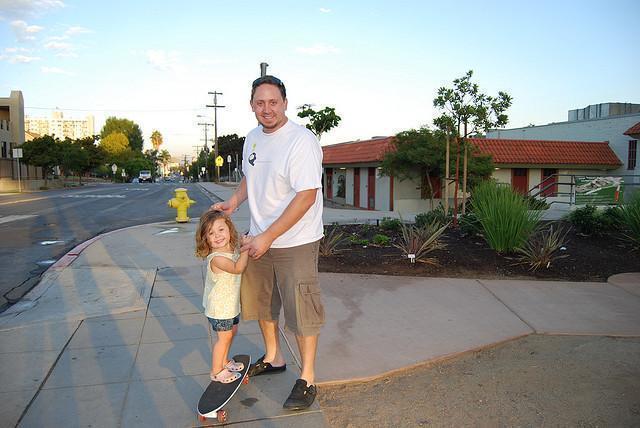What are the reddish and green plants called in the forefront of the planter?
Indicate the correct response and explain using: 'Answer: answer
Rationale: rationale.'
Options: Agapanthus, pampas grass, flax, lily. Answer: flax.
Rationale: There is a young girl posing with her dad. there standing in front of some plants that are pointy bushes as well as trees. 